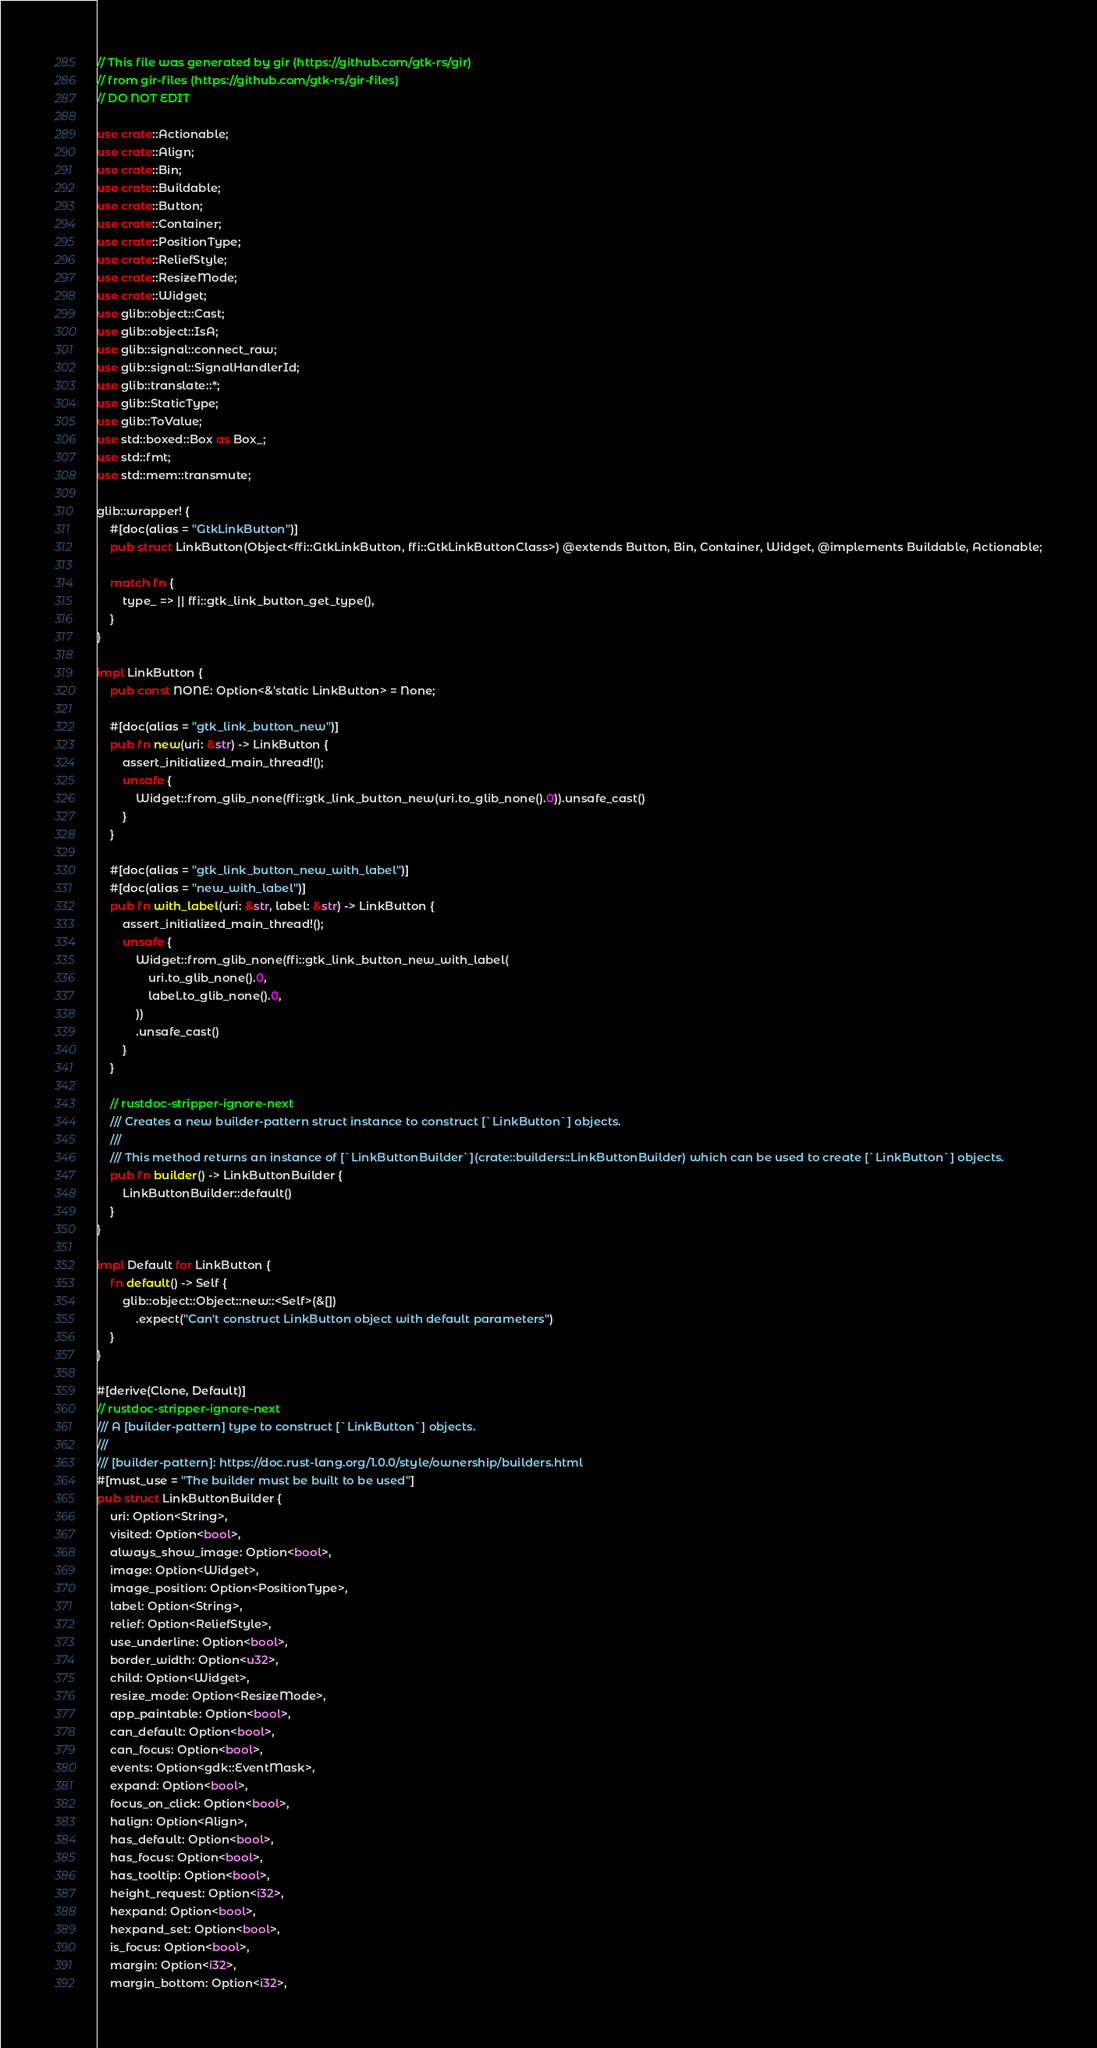<code> <loc_0><loc_0><loc_500><loc_500><_Rust_>// This file was generated by gir (https://github.com/gtk-rs/gir)
// from gir-files (https://github.com/gtk-rs/gir-files)
// DO NOT EDIT

use crate::Actionable;
use crate::Align;
use crate::Bin;
use crate::Buildable;
use crate::Button;
use crate::Container;
use crate::PositionType;
use crate::ReliefStyle;
use crate::ResizeMode;
use crate::Widget;
use glib::object::Cast;
use glib::object::IsA;
use glib::signal::connect_raw;
use glib::signal::SignalHandlerId;
use glib::translate::*;
use glib::StaticType;
use glib::ToValue;
use std::boxed::Box as Box_;
use std::fmt;
use std::mem::transmute;

glib::wrapper! {
    #[doc(alias = "GtkLinkButton")]
    pub struct LinkButton(Object<ffi::GtkLinkButton, ffi::GtkLinkButtonClass>) @extends Button, Bin, Container, Widget, @implements Buildable, Actionable;

    match fn {
        type_ => || ffi::gtk_link_button_get_type(),
    }
}

impl LinkButton {
    pub const NONE: Option<&'static LinkButton> = None;

    #[doc(alias = "gtk_link_button_new")]
    pub fn new(uri: &str) -> LinkButton {
        assert_initialized_main_thread!();
        unsafe {
            Widget::from_glib_none(ffi::gtk_link_button_new(uri.to_glib_none().0)).unsafe_cast()
        }
    }

    #[doc(alias = "gtk_link_button_new_with_label")]
    #[doc(alias = "new_with_label")]
    pub fn with_label(uri: &str, label: &str) -> LinkButton {
        assert_initialized_main_thread!();
        unsafe {
            Widget::from_glib_none(ffi::gtk_link_button_new_with_label(
                uri.to_glib_none().0,
                label.to_glib_none().0,
            ))
            .unsafe_cast()
        }
    }

    // rustdoc-stripper-ignore-next
    /// Creates a new builder-pattern struct instance to construct [`LinkButton`] objects.
    ///
    /// This method returns an instance of [`LinkButtonBuilder`](crate::builders::LinkButtonBuilder) which can be used to create [`LinkButton`] objects.
    pub fn builder() -> LinkButtonBuilder {
        LinkButtonBuilder::default()
    }
}

impl Default for LinkButton {
    fn default() -> Self {
        glib::object::Object::new::<Self>(&[])
            .expect("Can't construct LinkButton object with default parameters")
    }
}

#[derive(Clone, Default)]
// rustdoc-stripper-ignore-next
/// A [builder-pattern] type to construct [`LinkButton`] objects.
///
/// [builder-pattern]: https://doc.rust-lang.org/1.0.0/style/ownership/builders.html
#[must_use = "The builder must be built to be used"]
pub struct LinkButtonBuilder {
    uri: Option<String>,
    visited: Option<bool>,
    always_show_image: Option<bool>,
    image: Option<Widget>,
    image_position: Option<PositionType>,
    label: Option<String>,
    relief: Option<ReliefStyle>,
    use_underline: Option<bool>,
    border_width: Option<u32>,
    child: Option<Widget>,
    resize_mode: Option<ResizeMode>,
    app_paintable: Option<bool>,
    can_default: Option<bool>,
    can_focus: Option<bool>,
    events: Option<gdk::EventMask>,
    expand: Option<bool>,
    focus_on_click: Option<bool>,
    halign: Option<Align>,
    has_default: Option<bool>,
    has_focus: Option<bool>,
    has_tooltip: Option<bool>,
    height_request: Option<i32>,
    hexpand: Option<bool>,
    hexpand_set: Option<bool>,
    is_focus: Option<bool>,
    margin: Option<i32>,
    margin_bottom: Option<i32>,</code> 